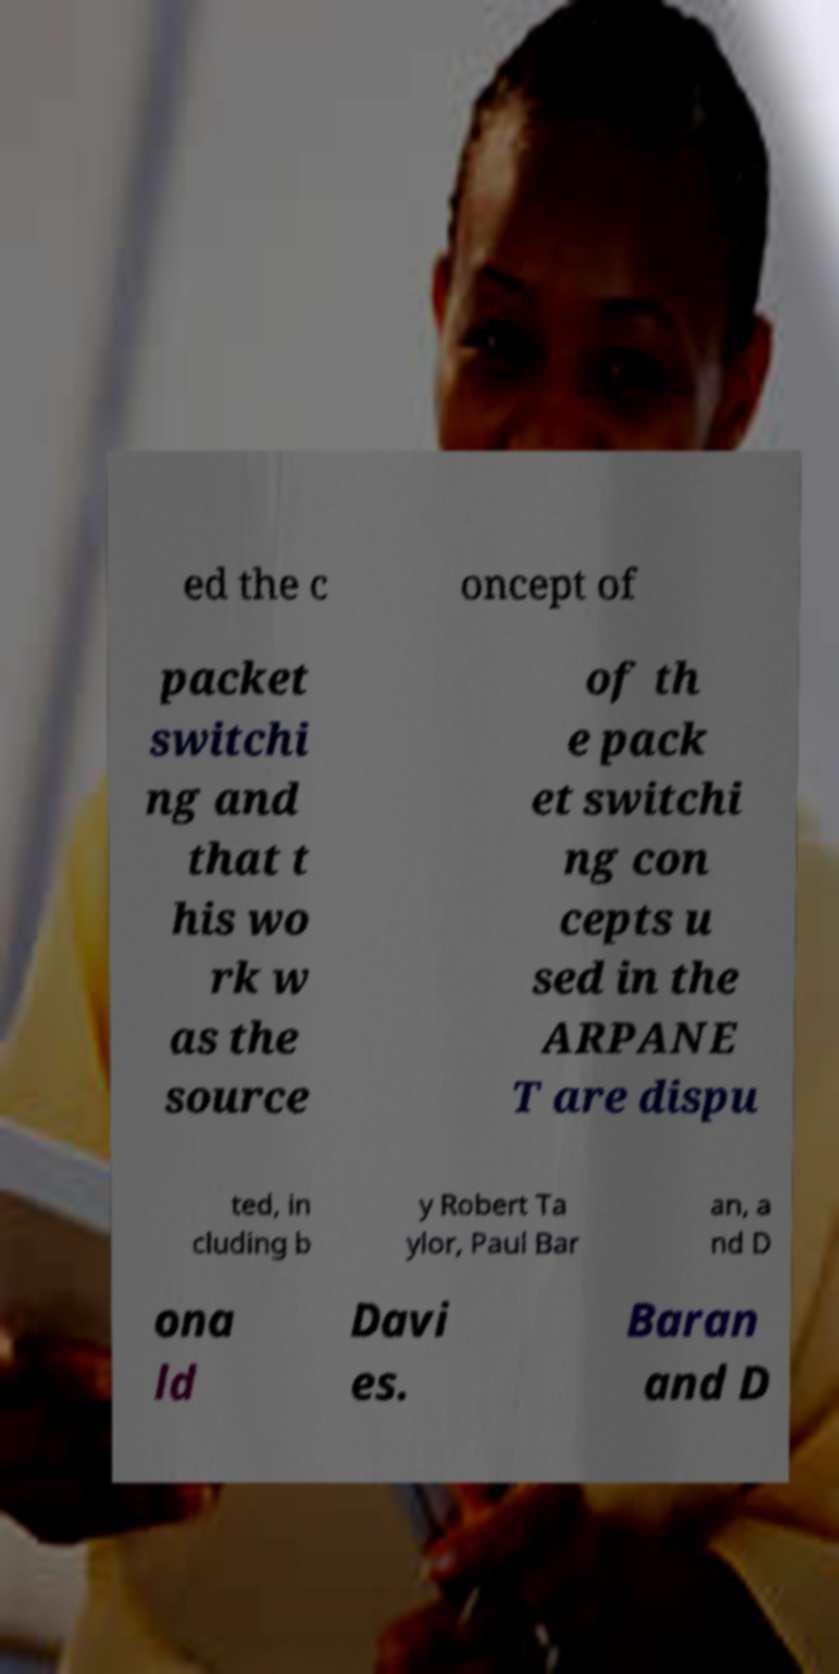What messages or text are displayed in this image? I need them in a readable, typed format. ed the c oncept of packet switchi ng and that t his wo rk w as the source of th e pack et switchi ng con cepts u sed in the ARPANE T are dispu ted, in cluding b y Robert Ta ylor, Paul Bar an, a nd D ona ld Davi es. Baran and D 